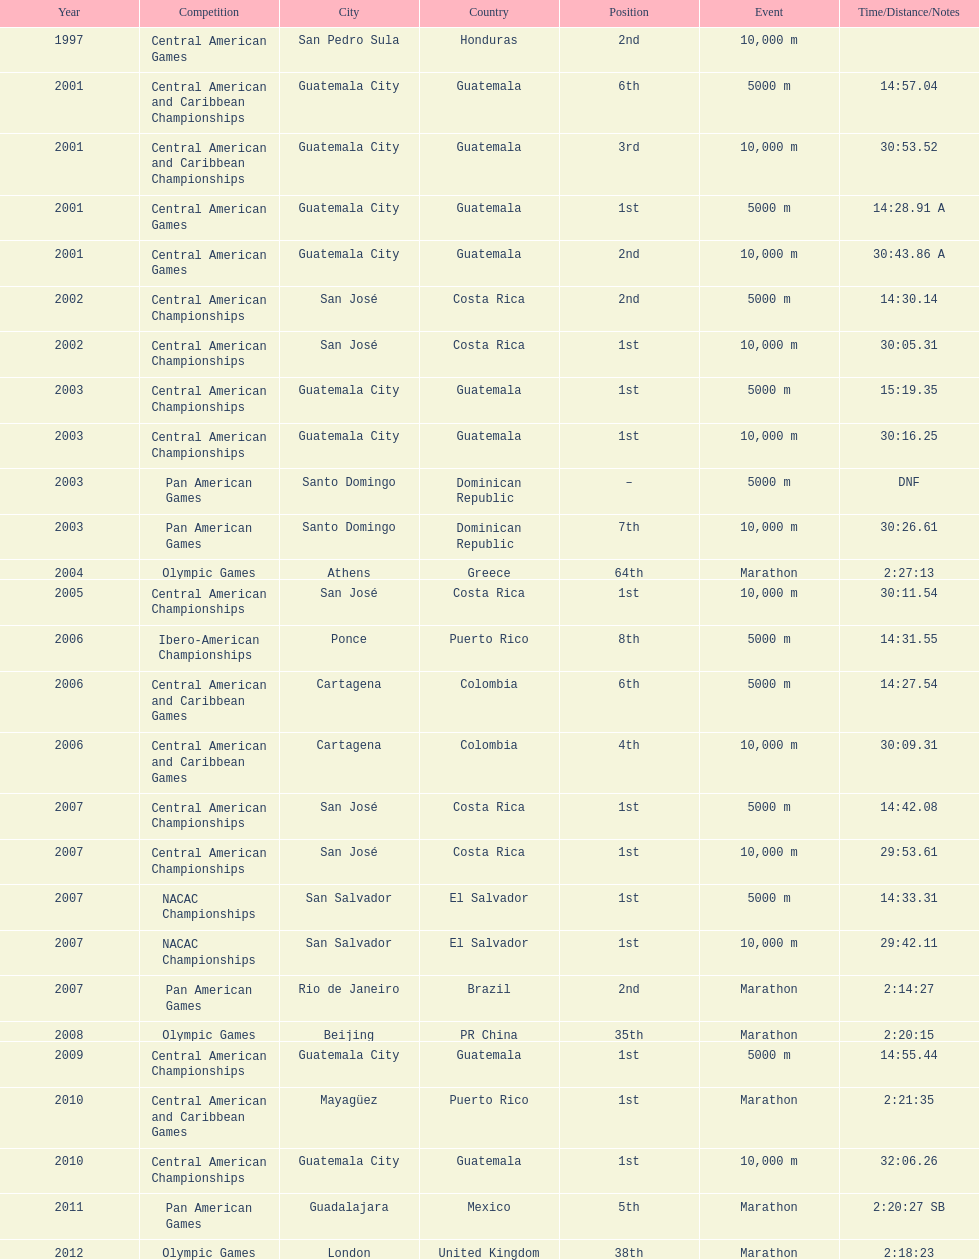Which of each game in 2007 was in the 2nd position? Pan American Games. 